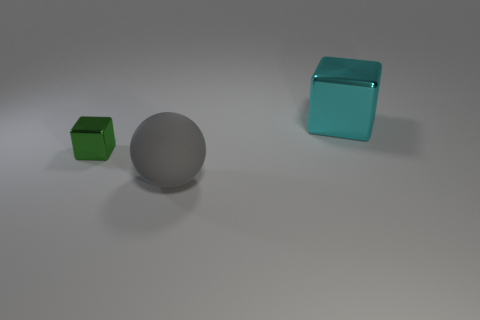What number of other objects are there of the same size as the green metallic thing?
Give a very brief answer. 0. There is a gray object; is it the same shape as the metallic thing that is to the right of the green object?
Offer a very short reply. No. Is the number of small green things greater than the number of large brown rubber spheres?
Offer a very short reply. Yes. What shape is the other object that is made of the same material as the green object?
Offer a very short reply. Cube. What is the material of the block that is in front of the metallic block on the right side of the green object?
Give a very brief answer. Metal. Is the shape of the shiny object left of the big cyan metal block the same as  the large cyan object?
Offer a very short reply. Yes. Is the number of big shiny cubes that are behind the big gray matte thing greater than the number of small brown objects?
Make the answer very short. Yes. Are there any other things that are the same material as the sphere?
Offer a terse response. No. What number of blocks are either gray objects or cyan things?
Make the answer very short. 1. What color is the metal thing that is on the right side of the metallic thing in front of the big cyan metal object?
Provide a succinct answer. Cyan. 